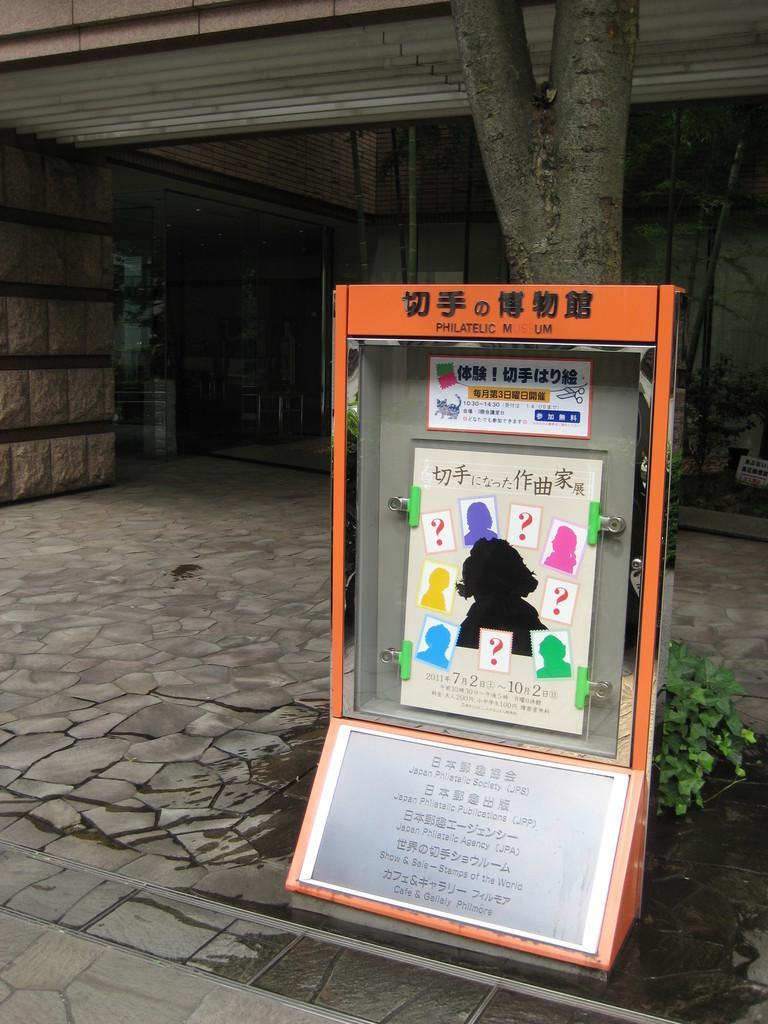Please provide a concise description of this image. In this picture I can see a board with paper clips inside a box, there is a plant, there are tree trunks, and there is a building. 